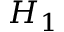<formula> <loc_0><loc_0><loc_500><loc_500>H _ { 1 }</formula> 